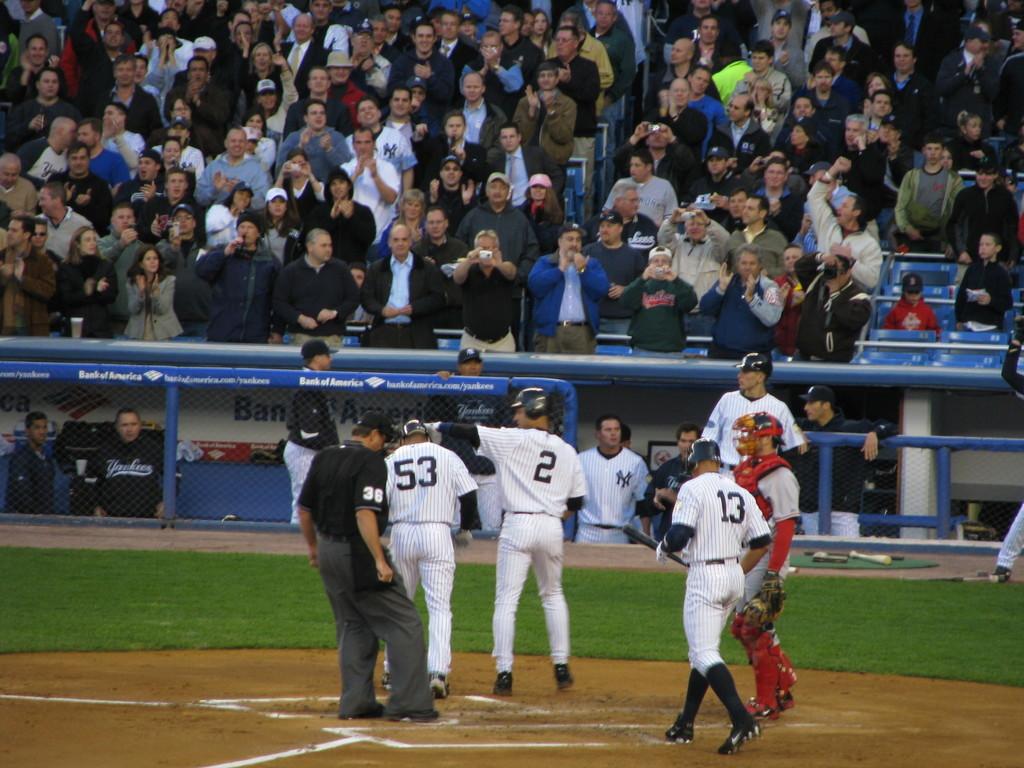What team are they playing for?
Your response must be concise. Yankees. 